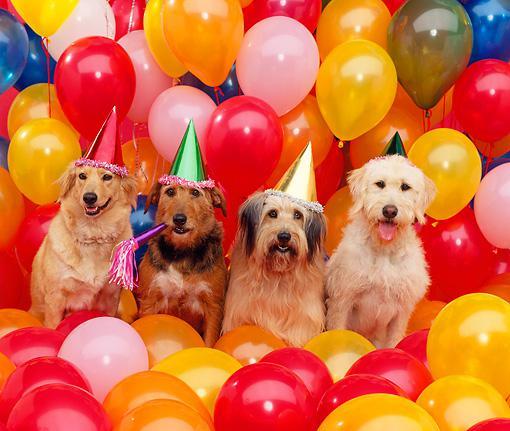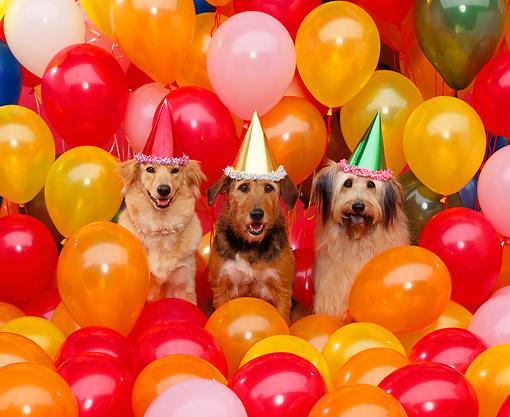The first image is the image on the left, the second image is the image on the right. Given the left and right images, does the statement "Each image includes at least one dog wearing a cone-shaped party hat with balloons floating behind it." hold true? Answer yes or no. Yes. The first image is the image on the left, the second image is the image on the right. Examine the images to the left and right. Is the description "There is exactly one dog in the right image." accurate? Answer yes or no. No. 